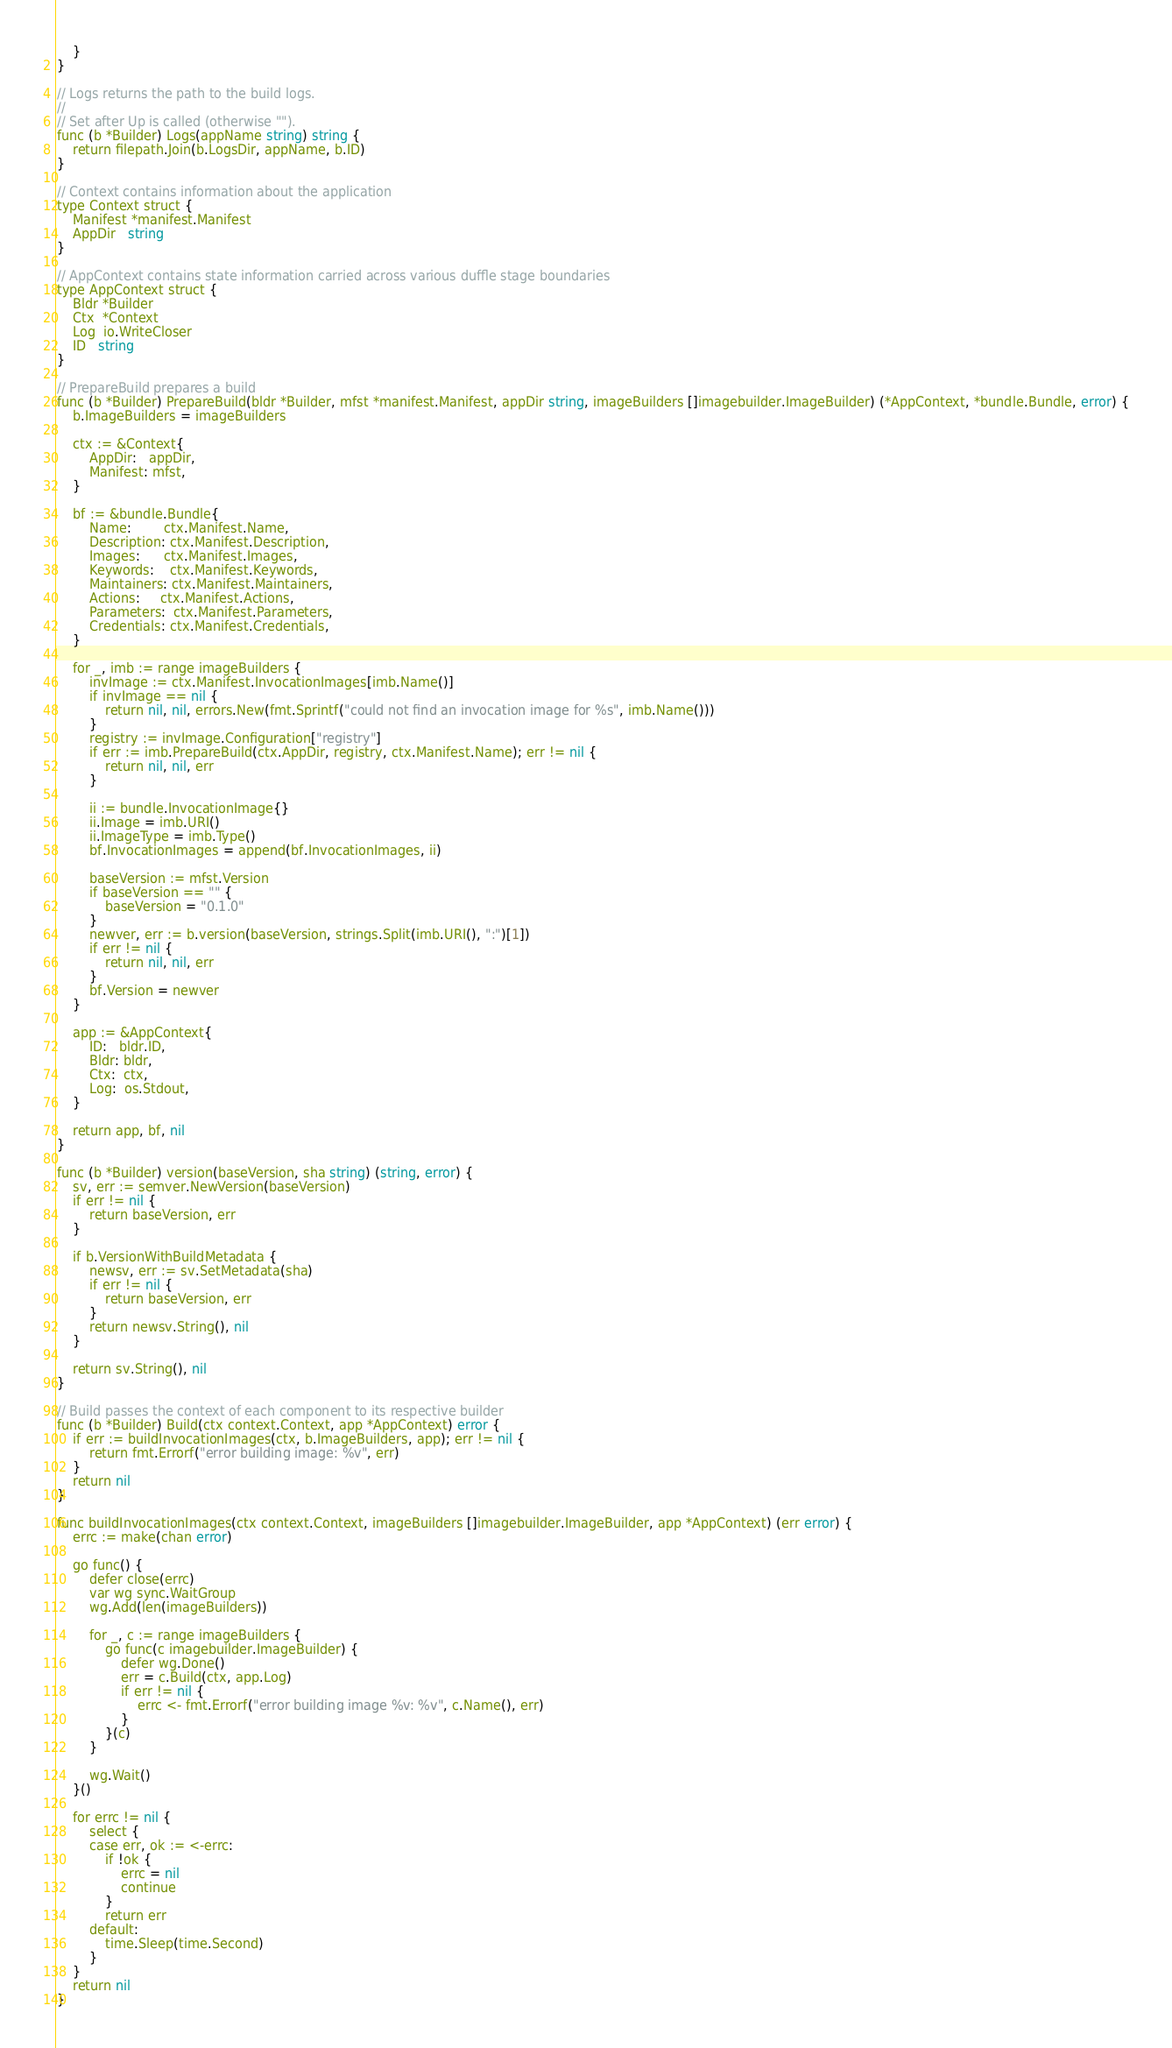Convert code to text. <code><loc_0><loc_0><loc_500><loc_500><_Go_>	}
}

// Logs returns the path to the build logs.
//
// Set after Up is called (otherwise "").
func (b *Builder) Logs(appName string) string {
	return filepath.Join(b.LogsDir, appName, b.ID)
}

// Context contains information about the application
type Context struct {
	Manifest *manifest.Manifest
	AppDir   string
}

// AppContext contains state information carried across various duffle stage boundaries
type AppContext struct {
	Bldr *Builder
	Ctx  *Context
	Log  io.WriteCloser
	ID   string
}

// PrepareBuild prepares a build
func (b *Builder) PrepareBuild(bldr *Builder, mfst *manifest.Manifest, appDir string, imageBuilders []imagebuilder.ImageBuilder) (*AppContext, *bundle.Bundle, error) {
	b.ImageBuilders = imageBuilders

	ctx := &Context{
		AppDir:   appDir,
		Manifest: mfst,
	}

	bf := &bundle.Bundle{
		Name:        ctx.Manifest.Name,
		Description: ctx.Manifest.Description,
		Images:      ctx.Manifest.Images,
		Keywords:    ctx.Manifest.Keywords,
		Maintainers: ctx.Manifest.Maintainers,
		Actions:     ctx.Manifest.Actions,
		Parameters:  ctx.Manifest.Parameters,
		Credentials: ctx.Manifest.Credentials,
	}

	for _, imb := range imageBuilders {
		invImage := ctx.Manifest.InvocationImages[imb.Name()]
		if invImage == nil {
			return nil, nil, errors.New(fmt.Sprintf("could not find an invocation image for %s", imb.Name()))
		}
		registry := invImage.Configuration["registry"]
		if err := imb.PrepareBuild(ctx.AppDir, registry, ctx.Manifest.Name); err != nil {
			return nil, nil, err
		}

		ii := bundle.InvocationImage{}
		ii.Image = imb.URI()
		ii.ImageType = imb.Type()
		bf.InvocationImages = append(bf.InvocationImages, ii)

		baseVersion := mfst.Version
		if baseVersion == "" {
			baseVersion = "0.1.0"
		}
		newver, err := b.version(baseVersion, strings.Split(imb.URI(), ":")[1])
		if err != nil {
			return nil, nil, err
		}
		bf.Version = newver
	}

	app := &AppContext{
		ID:   bldr.ID,
		Bldr: bldr,
		Ctx:  ctx,
		Log:  os.Stdout,
	}

	return app, bf, nil
}

func (b *Builder) version(baseVersion, sha string) (string, error) {
	sv, err := semver.NewVersion(baseVersion)
	if err != nil {
		return baseVersion, err
	}

	if b.VersionWithBuildMetadata {
		newsv, err := sv.SetMetadata(sha)
		if err != nil {
			return baseVersion, err
		}
		return newsv.String(), nil
	}

	return sv.String(), nil
}

// Build passes the context of each component to its respective builder
func (b *Builder) Build(ctx context.Context, app *AppContext) error {
	if err := buildInvocationImages(ctx, b.ImageBuilders, app); err != nil {
		return fmt.Errorf("error building image: %v", err)
	}
	return nil
}

func buildInvocationImages(ctx context.Context, imageBuilders []imagebuilder.ImageBuilder, app *AppContext) (err error) {
	errc := make(chan error)

	go func() {
		defer close(errc)
		var wg sync.WaitGroup
		wg.Add(len(imageBuilders))

		for _, c := range imageBuilders {
			go func(c imagebuilder.ImageBuilder) {
				defer wg.Done()
				err = c.Build(ctx, app.Log)
				if err != nil {
					errc <- fmt.Errorf("error building image %v: %v", c.Name(), err)
				}
			}(c)
		}

		wg.Wait()
	}()

	for errc != nil {
		select {
		case err, ok := <-errc:
			if !ok {
				errc = nil
				continue
			}
			return err
		default:
			time.Sleep(time.Second)
		}
	}
	return nil
}
</code> 